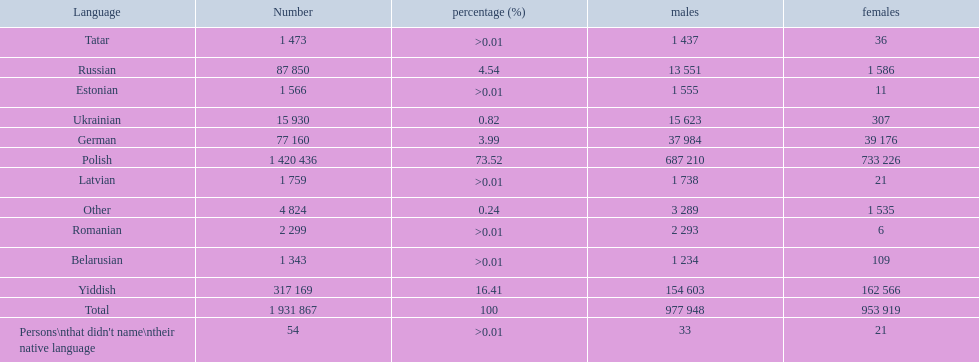What are all the spoken languages? Polish, Yiddish, Russian, German, Ukrainian, Romanian, Latvian, Estonian, Tatar, Belarusian. Which one of these has the most people speaking it? Polish. 